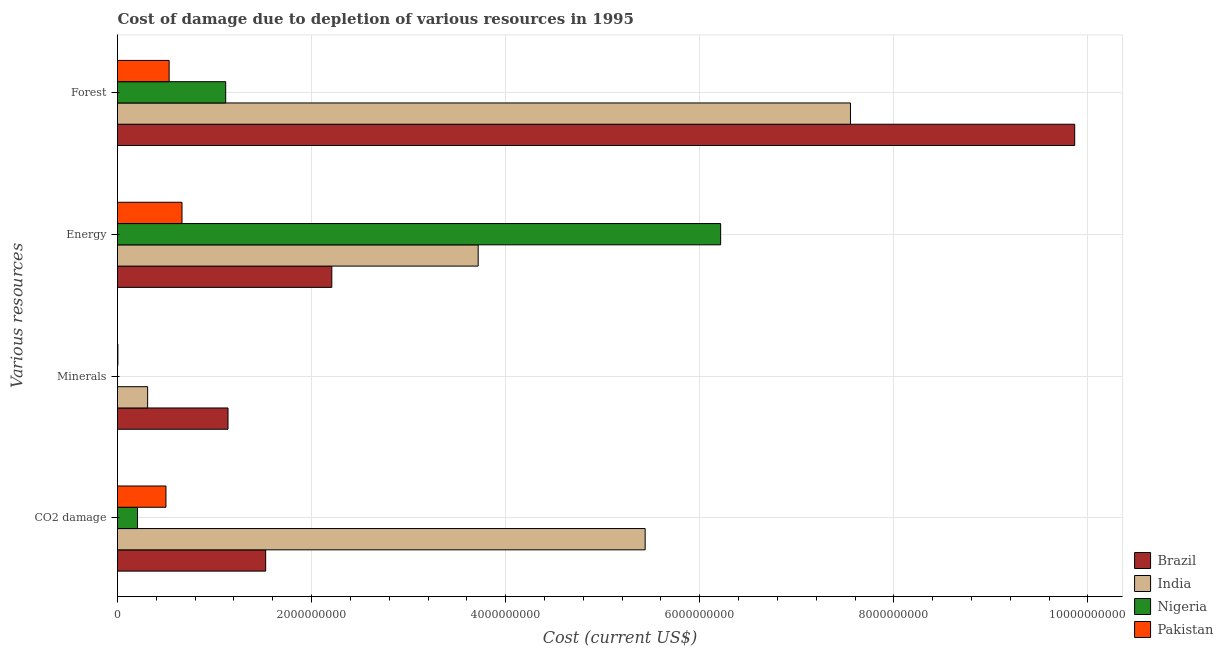Are the number of bars per tick equal to the number of legend labels?
Your answer should be very brief. Yes. Are the number of bars on each tick of the Y-axis equal?
Make the answer very short. Yes. What is the label of the 2nd group of bars from the top?
Your response must be concise. Energy. What is the cost of damage due to depletion of energy in Nigeria?
Keep it short and to the point. 6.21e+09. Across all countries, what is the maximum cost of damage due to depletion of forests?
Your response must be concise. 9.86e+09. Across all countries, what is the minimum cost of damage due to depletion of forests?
Your answer should be very brief. 5.32e+08. In which country was the cost of damage due to depletion of minerals maximum?
Ensure brevity in your answer.  Brazil. In which country was the cost of damage due to depletion of minerals minimum?
Provide a short and direct response. Nigeria. What is the total cost of damage due to depletion of minerals in the graph?
Provide a succinct answer. 1.45e+09. What is the difference between the cost of damage due to depletion of forests in Brazil and that in Pakistan?
Keep it short and to the point. 9.33e+09. What is the difference between the cost of damage due to depletion of minerals in Brazil and the cost of damage due to depletion of coal in India?
Offer a terse response. -4.30e+09. What is the average cost of damage due to depletion of forests per country?
Keep it short and to the point. 4.77e+09. What is the difference between the cost of damage due to depletion of minerals and cost of damage due to depletion of coal in India?
Offer a very short reply. -5.13e+09. In how many countries, is the cost of damage due to depletion of energy greater than 3200000000 US$?
Provide a succinct answer. 2. What is the ratio of the cost of damage due to depletion of forests in Brazil to that in India?
Ensure brevity in your answer.  1.31. Is the cost of damage due to depletion of coal in India less than that in Brazil?
Keep it short and to the point. No. Is the difference between the cost of damage due to depletion of energy in India and Brazil greater than the difference between the cost of damage due to depletion of minerals in India and Brazil?
Your answer should be very brief. Yes. What is the difference between the highest and the second highest cost of damage due to depletion of coal?
Ensure brevity in your answer.  3.91e+09. What is the difference between the highest and the lowest cost of damage due to depletion of forests?
Make the answer very short. 9.33e+09. Is it the case that in every country, the sum of the cost of damage due to depletion of minerals and cost of damage due to depletion of energy is greater than the sum of cost of damage due to depletion of forests and cost of damage due to depletion of coal?
Give a very brief answer. No. What does the 2nd bar from the top in Forest represents?
Keep it short and to the point. Nigeria. Is it the case that in every country, the sum of the cost of damage due to depletion of coal and cost of damage due to depletion of minerals is greater than the cost of damage due to depletion of energy?
Your answer should be compact. No. What is the difference between two consecutive major ticks on the X-axis?
Your response must be concise. 2.00e+09. Does the graph contain grids?
Offer a very short reply. Yes. Where does the legend appear in the graph?
Offer a very short reply. Bottom right. What is the title of the graph?
Your answer should be very brief. Cost of damage due to depletion of various resources in 1995 . What is the label or title of the X-axis?
Provide a succinct answer. Cost (current US$). What is the label or title of the Y-axis?
Your answer should be compact. Various resources. What is the Cost (current US$) in Brazil in CO2 damage?
Offer a terse response. 1.53e+09. What is the Cost (current US$) in India in CO2 damage?
Your answer should be very brief. 5.44e+09. What is the Cost (current US$) in Nigeria in CO2 damage?
Make the answer very short. 2.06e+08. What is the Cost (current US$) in Pakistan in CO2 damage?
Give a very brief answer. 4.99e+08. What is the Cost (current US$) in Brazil in Minerals?
Offer a very short reply. 1.14e+09. What is the Cost (current US$) in India in Minerals?
Provide a short and direct response. 3.10e+08. What is the Cost (current US$) in Nigeria in Minerals?
Your response must be concise. 2.12e+05. What is the Cost (current US$) in Pakistan in Minerals?
Offer a terse response. 3.95e+06. What is the Cost (current US$) of Brazil in Energy?
Your response must be concise. 2.21e+09. What is the Cost (current US$) of India in Energy?
Offer a very short reply. 3.72e+09. What is the Cost (current US$) in Nigeria in Energy?
Make the answer very short. 6.21e+09. What is the Cost (current US$) in Pakistan in Energy?
Make the answer very short. 6.64e+08. What is the Cost (current US$) in Brazil in Forest?
Make the answer very short. 9.86e+09. What is the Cost (current US$) of India in Forest?
Keep it short and to the point. 7.55e+09. What is the Cost (current US$) of Nigeria in Forest?
Your response must be concise. 1.11e+09. What is the Cost (current US$) in Pakistan in Forest?
Provide a short and direct response. 5.32e+08. Across all Various resources, what is the maximum Cost (current US$) in Brazil?
Ensure brevity in your answer.  9.86e+09. Across all Various resources, what is the maximum Cost (current US$) of India?
Make the answer very short. 7.55e+09. Across all Various resources, what is the maximum Cost (current US$) in Nigeria?
Offer a terse response. 6.21e+09. Across all Various resources, what is the maximum Cost (current US$) in Pakistan?
Your response must be concise. 6.64e+08. Across all Various resources, what is the minimum Cost (current US$) in Brazil?
Your answer should be compact. 1.14e+09. Across all Various resources, what is the minimum Cost (current US$) of India?
Give a very brief answer. 3.10e+08. Across all Various resources, what is the minimum Cost (current US$) in Nigeria?
Your response must be concise. 2.12e+05. Across all Various resources, what is the minimum Cost (current US$) in Pakistan?
Make the answer very short. 3.95e+06. What is the total Cost (current US$) of Brazil in the graph?
Offer a very short reply. 1.47e+1. What is the total Cost (current US$) in India in the graph?
Your answer should be very brief. 1.70e+1. What is the total Cost (current US$) of Nigeria in the graph?
Your response must be concise. 7.54e+09. What is the total Cost (current US$) in Pakistan in the graph?
Offer a very short reply. 1.70e+09. What is the difference between the Cost (current US$) of Brazil in CO2 damage and that in Minerals?
Give a very brief answer. 3.88e+08. What is the difference between the Cost (current US$) in India in CO2 damage and that in Minerals?
Give a very brief answer. 5.13e+09. What is the difference between the Cost (current US$) of Nigeria in CO2 damage and that in Minerals?
Make the answer very short. 2.06e+08. What is the difference between the Cost (current US$) in Pakistan in CO2 damage and that in Minerals?
Your answer should be very brief. 4.95e+08. What is the difference between the Cost (current US$) of Brazil in CO2 damage and that in Energy?
Your response must be concise. -6.82e+08. What is the difference between the Cost (current US$) in India in CO2 damage and that in Energy?
Offer a terse response. 1.72e+09. What is the difference between the Cost (current US$) of Nigeria in CO2 damage and that in Energy?
Provide a succinct answer. -6.01e+09. What is the difference between the Cost (current US$) of Pakistan in CO2 damage and that in Energy?
Your response must be concise. -1.65e+08. What is the difference between the Cost (current US$) of Brazil in CO2 damage and that in Forest?
Your answer should be very brief. -8.34e+09. What is the difference between the Cost (current US$) of India in CO2 damage and that in Forest?
Provide a succinct answer. -2.12e+09. What is the difference between the Cost (current US$) of Nigeria in CO2 damage and that in Forest?
Keep it short and to the point. -9.09e+08. What is the difference between the Cost (current US$) of Pakistan in CO2 damage and that in Forest?
Your response must be concise. -3.27e+07. What is the difference between the Cost (current US$) of Brazil in Minerals and that in Energy?
Your response must be concise. -1.07e+09. What is the difference between the Cost (current US$) of India in Minerals and that in Energy?
Provide a short and direct response. -3.41e+09. What is the difference between the Cost (current US$) of Nigeria in Minerals and that in Energy?
Provide a succinct answer. -6.21e+09. What is the difference between the Cost (current US$) in Pakistan in Minerals and that in Energy?
Provide a short and direct response. -6.61e+08. What is the difference between the Cost (current US$) in Brazil in Minerals and that in Forest?
Provide a succinct answer. -8.72e+09. What is the difference between the Cost (current US$) in India in Minerals and that in Forest?
Keep it short and to the point. -7.24e+09. What is the difference between the Cost (current US$) of Nigeria in Minerals and that in Forest?
Your answer should be very brief. -1.11e+09. What is the difference between the Cost (current US$) of Pakistan in Minerals and that in Forest?
Keep it short and to the point. -5.28e+08. What is the difference between the Cost (current US$) of Brazil in Energy and that in Forest?
Your answer should be compact. -7.65e+09. What is the difference between the Cost (current US$) of India in Energy and that in Forest?
Provide a short and direct response. -3.84e+09. What is the difference between the Cost (current US$) in Nigeria in Energy and that in Forest?
Your response must be concise. 5.10e+09. What is the difference between the Cost (current US$) in Pakistan in Energy and that in Forest?
Keep it short and to the point. 1.32e+08. What is the difference between the Cost (current US$) in Brazil in CO2 damage and the Cost (current US$) in India in Minerals?
Give a very brief answer. 1.22e+09. What is the difference between the Cost (current US$) in Brazil in CO2 damage and the Cost (current US$) in Nigeria in Minerals?
Keep it short and to the point. 1.53e+09. What is the difference between the Cost (current US$) of Brazil in CO2 damage and the Cost (current US$) of Pakistan in Minerals?
Offer a very short reply. 1.52e+09. What is the difference between the Cost (current US$) in India in CO2 damage and the Cost (current US$) in Nigeria in Minerals?
Provide a short and direct response. 5.44e+09. What is the difference between the Cost (current US$) of India in CO2 damage and the Cost (current US$) of Pakistan in Minerals?
Provide a short and direct response. 5.43e+09. What is the difference between the Cost (current US$) of Nigeria in CO2 damage and the Cost (current US$) of Pakistan in Minerals?
Keep it short and to the point. 2.02e+08. What is the difference between the Cost (current US$) in Brazil in CO2 damage and the Cost (current US$) in India in Energy?
Offer a terse response. -2.19e+09. What is the difference between the Cost (current US$) in Brazil in CO2 damage and the Cost (current US$) in Nigeria in Energy?
Your response must be concise. -4.69e+09. What is the difference between the Cost (current US$) of Brazil in CO2 damage and the Cost (current US$) of Pakistan in Energy?
Keep it short and to the point. 8.62e+08. What is the difference between the Cost (current US$) of India in CO2 damage and the Cost (current US$) of Nigeria in Energy?
Make the answer very short. -7.78e+08. What is the difference between the Cost (current US$) in India in CO2 damage and the Cost (current US$) in Pakistan in Energy?
Ensure brevity in your answer.  4.77e+09. What is the difference between the Cost (current US$) in Nigeria in CO2 damage and the Cost (current US$) in Pakistan in Energy?
Your response must be concise. -4.58e+08. What is the difference between the Cost (current US$) in Brazil in CO2 damage and the Cost (current US$) in India in Forest?
Your response must be concise. -6.03e+09. What is the difference between the Cost (current US$) in Brazil in CO2 damage and the Cost (current US$) in Nigeria in Forest?
Keep it short and to the point. 4.12e+08. What is the difference between the Cost (current US$) of Brazil in CO2 damage and the Cost (current US$) of Pakistan in Forest?
Offer a terse response. 9.95e+08. What is the difference between the Cost (current US$) of India in CO2 damage and the Cost (current US$) of Nigeria in Forest?
Offer a very short reply. 4.32e+09. What is the difference between the Cost (current US$) in India in CO2 damage and the Cost (current US$) in Pakistan in Forest?
Your answer should be very brief. 4.90e+09. What is the difference between the Cost (current US$) in Nigeria in CO2 damage and the Cost (current US$) in Pakistan in Forest?
Keep it short and to the point. -3.26e+08. What is the difference between the Cost (current US$) in Brazil in Minerals and the Cost (current US$) in India in Energy?
Provide a short and direct response. -2.58e+09. What is the difference between the Cost (current US$) in Brazil in Minerals and the Cost (current US$) in Nigeria in Energy?
Offer a terse response. -5.08e+09. What is the difference between the Cost (current US$) of Brazil in Minerals and the Cost (current US$) of Pakistan in Energy?
Keep it short and to the point. 4.74e+08. What is the difference between the Cost (current US$) of India in Minerals and the Cost (current US$) of Nigeria in Energy?
Your response must be concise. -5.90e+09. What is the difference between the Cost (current US$) in India in Minerals and the Cost (current US$) in Pakistan in Energy?
Give a very brief answer. -3.54e+08. What is the difference between the Cost (current US$) in Nigeria in Minerals and the Cost (current US$) in Pakistan in Energy?
Make the answer very short. -6.64e+08. What is the difference between the Cost (current US$) of Brazil in Minerals and the Cost (current US$) of India in Forest?
Make the answer very short. -6.41e+09. What is the difference between the Cost (current US$) in Brazil in Minerals and the Cost (current US$) in Nigeria in Forest?
Offer a very short reply. 2.37e+07. What is the difference between the Cost (current US$) of Brazil in Minerals and the Cost (current US$) of Pakistan in Forest?
Ensure brevity in your answer.  6.07e+08. What is the difference between the Cost (current US$) in India in Minerals and the Cost (current US$) in Nigeria in Forest?
Your answer should be very brief. -8.04e+08. What is the difference between the Cost (current US$) of India in Minerals and the Cost (current US$) of Pakistan in Forest?
Provide a succinct answer. -2.22e+08. What is the difference between the Cost (current US$) in Nigeria in Minerals and the Cost (current US$) in Pakistan in Forest?
Give a very brief answer. -5.32e+08. What is the difference between the Cost (current US$) of Brazil in Energy and the Cost (current US$) of India in Forest?
Ensure brevity in your answer.  -5.34e+09. What is the difference between the Cost (current US$) in Brazil in Energy and the Cost (current US$) in Nigeria in Forest?
Offer a very short reply. 1.09e+09. What is the difference between the Cost (current US$) of Brazil in Energy and the Cost (current US$) of Pakistan in Forest?
Keep it short and to the point. 1.68e+09. What is the difference between the Cost (current US$) of India in Energy and the Cost (current US$) of Nigeria in Forest?
Give a very brief answer. 2.60e+09. What is the difference between the Cost (current US$) of India in Energy and the Cost (current US$) of Pakistan in Forest?
Your response must be concise. 3.18e+09. What is the difference between the Cost (current US$) in Nigeria in Energy and the Cost (current US$) in Pakistan in Forest?
Your response must be concise. 5.68e+09. What is the average Cost (current US$) in Brazil per Various resources?
Keep it short and to the point. 3.68e+09. What is the average Cost (current US$) in India per Various resources?
Provide a short and direct response. 4.25e+09. What is the average Cost (current US$) in Nigeria per Various resources?
Make the answer very short. 1.88e+09. What is the average Cost (current US$) in Pakistan per Various resources?
Keep it short and to the point. 4.25e+08. What is the difference between the Cost (current US$) in Brazil and Cost (current US$) in India in CO2 damage?
Your response must be concise. -3.91e+09. What is the difference between the Cost (current US$) of Brazil and Cost (current US$) of Nigeria in CO2 damage?
Your answer should be very brief. 1.32e+09. What is the difference between the Cost (current US$) of Brazil and Cost (current US$) of Pakistan in CO2 damage?
Offer a terse response. 1.03e+09. What is the difference between the Cost (current US$) in India and Cost (current US$) in Nigeria in CO2 damage?
Your response must be concise. 5.23e+09. What is the difference between the Cost (current US$) of India and Cost (current US$) of Pakistan in CO2 damage?
Your response must be concise. 4.94e+09. What is the difference between the Cost (current US$) of Nigeria and Cost (current US$) of Pakistan in CO2 damage?
Your answer should be very brief. -2.93e+08. What is the difference between the Cost (current US$) of Brazil and Cost (current US$) of India in Minerals?
Give a very brief answer. 8.28e+08. What is the difference between the Cost (current US$) of Brazil and Cost (current US$) of Nigeria in Minerals?
Give a very brief answer. 1.14e+09. What is the difference between the Cost (current US$) in Brazil and Cost (current US$) in Pakistan in Minerals?
Your answer should be compact. 1.13e+09. What is the difference between the Cost (current US$) in India and Cost (current US$) in Nigeria in Minerals?
Ensure brevity in your answer.  3.10e+08. What is the difference between the Cost (current US$) in India and Cost (current US$) in Pakistan in Minerals?
Offer a very short reply. 3.07e+08. What is the difference between the Cost (current US$) of Nigeria and Cost (current US$) of Pakistan in Minerals?
Keep it short and to the point. -3.74e+06. What is the difference between the Cost (current US$) of Brazil and Cost (current US$) of India in Energy?
Your answer should be compact. -1.51e+09. What is the difference between the Cost (current US$) in Brazil and Cost (current US$) in Nigeria in Energy?
Your answer should be compact. -4.01e+09. What is the difference between the Cost (current US$) in Brazil and Cost (current US$) in Pakistan in Energy?
Make the answer very short. 1.54e+09. What is the difference between the Cost (current US$) of India and Cost (current US$) of Nigeria in Energy?
Offer a terse response. -2.50e+09. What is the difference between the Cost (current US$) of India and Cost (current US$) of Pakistan in Energy?
Offer a very short reply. 3.05e+09. What is the difference between the Cost (current US$) of Nigeria and Cost (current US$) of Pakistan in Energy?
Provide a succinct answer. 5.55e+09. What is the difference between the Cost (current US$) of Brazil and Cost (current US$) of India in Forest?
Keep it short and to the point. 2.31e+09. What is the difference between the Cost (current US$) of Brazil and Cost (current US$) of Nigeria in Forest?
Your answer should be very brief. 8.75e+09. What is the difference between the Cost (current US$) of Brazil and Cost (current US$) of Pakistan in Forest?
Your response must be concise. 9.33e+09. What is the difference between the Cost (current US$) of India and Cost (current US$) of Nigeria in Forest?
Provide a short and direct response. 6.44e+09. What is the difference between the Cost (current US$) in India and Cost (current US$) in Pakistan in Forest?
Keep it short and to the point. 7.02e+09. What is the difference between the Cost (current US$) of Nigeria and Cost (current US$) of Pakistan in Forest?
Your answer should be compact. 5.83e+08. What is the ratio of the Cost (current US$) in Brazil in CO2 damage to that in Minerals?
Give a very brief answer. 1.34. What is the ratio of the Cost (current US$) of India in CO2 damage to that in Minerals?
Ensure brevity in your answer.  17.51. What is the ratio of the Cost (current US$) in Nigeria in CO2 damage to that in Minerals?
Offer a very short reply. 973.16. What is the ratio of the Cost (current US$) of Pakistan in CO2 damage to that in Minerals?
Provide a short and direct response. 126.35. What is the ratio of the Cost (current US$) in Brazil in CO2 damage to that in Energy?
Give a very brief answer. 0.69. What is the ratio of the Cost (current US$) in India in CO2 damage to that in Energy?
Make the answer very short. 1.46. What is the ratio of the Cost (current US$) in Nigeria in CO2 damage to that in Energy?
Offer a terse response. 0.03. What is the ratio of the Cost (current US$) in Pakistan in CO2 damage to that in Energy?
Your answer should be compact. 0.75. What is the ratio of the Cost (current US$) of Brazil in CO2 damage to that in Forest?
Keep it short and to the point. 0.15. What is the ratio of the Cost (current US$) of India in CO2 damage to that in Forest?
Offer a very short reply. 0.72. What is the ratio of the Cost (current US$) of Nigeria in CO2 damage to that in Forest?
Offer a very short reply. 0.19. What is the ratio of the Cost (current US$) in Pakistan in CO2 damage to that in Forest?
Give a very brief answer. 0.94. What is the ratio of the Cost (current US$) of Brazil in Minerals to that in Energy?
Keep it short and to the point. 0.52. What is the ratio of the Cost (current US$) in India in Minerals to that in Energy?
Make the answer very short. 0.08. What is the ratio of the Cost (current US$) of Nigeria in Minerals to that in Energy?
Make the answer very short. 0. What is the ratio of the Cost (current US$) in Pakistan in Minerals to that in Energy?
Make the answer very short. 0.01. What is the ratio of the Cost (current US$) of Brazil in Minerals to that in Forest?
Make the answer very short. 0.12. What is the ratio of the Cost (current US$) in India in Minerals to that in Forest?
Make the answer very short. 0.04. What is the ratio of the Cost (current US$) of Nigeria in Minerals to that in Forest?
Ensure brevity in your answer.  0. What is the ratio of the Cost (current US$) of Pakistan in Minerals to that in Forest?
Your answer should be compact. 0.01. What is the ratio of the Cost (current US$) of Brazil in Energy to that in Forest?
Keep it short and to the point. 0.22. What is the ratio of the Cost (current US$) in India in Energy to that in Forest?
Your response must be concise. 0.49. What is the ratio of the Cost (current US$) of Nigeria in Energy to that in Forest?
Offer a very short reply. 5.57. What is the ratio of the Cost (current US$) of Pakistan in Energy to that in Forest?
Give a very brief answer. 1.25. What is the difference between the highest and the second highest Cost (current US$) in Brazil?
Keep it short and to the point. 7.65e+09. What is the difference between the highest and the second highest Cost (current US$) in India?
Make the answer very short. 2.12e+09. What is the difference between the highest and the second highest Cost (current US$) of Nigeria?
Your response must be concise. 5.10e+09. What is the difference between the highest and the second highest Cost (current US$) in Pakistan?
Your answer should be compact. 1.32e+08. What is the difference between the highest and the lowest Cost (current US$) in Brazil?
Provide a succinct answer. 8.72e+09. What is the difference between the highest and the lowest Cost (current US$) of India?
Keep it short and to the point. 7.24e+09. What is the difference between the highest and the lowest Cost (current US$) in Nigeria?
Your answer should be very brief. 6.21e+09. What is the difference between the highest and the lowest Cost (current US$) of Pakistan?
Your answer should be compact. 6.61e+08. 